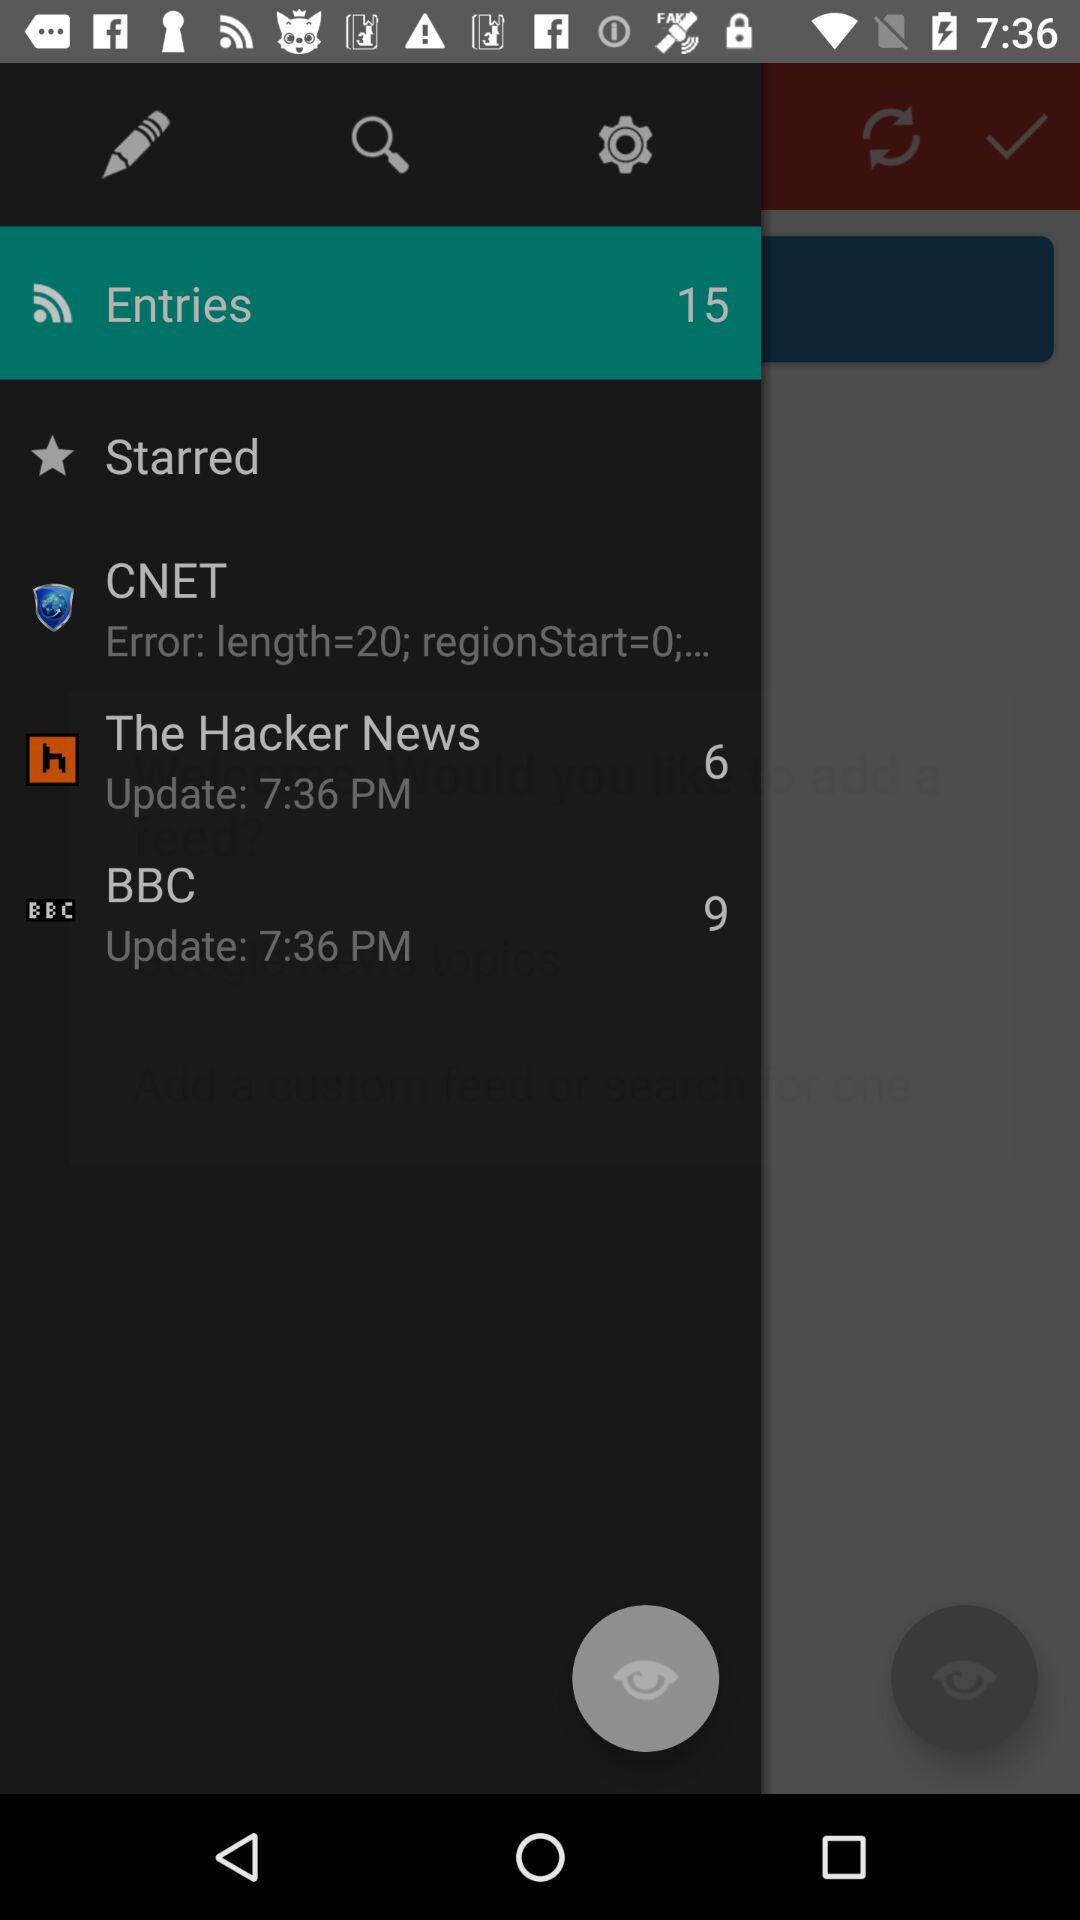How many items are in "The Hacker News"? There are 6 items in "The Hacker News". 